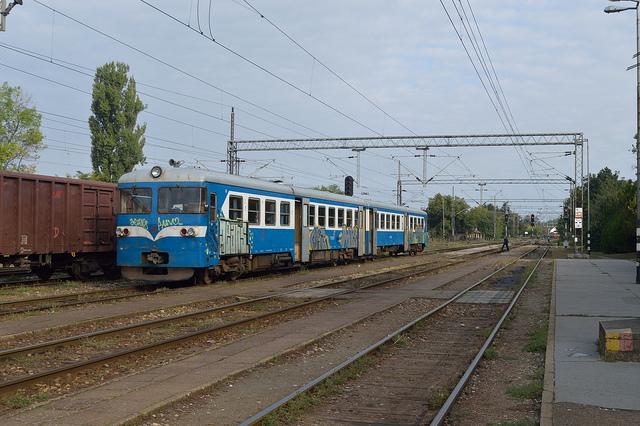How many tracks are seen?
Give a very brief answer. 3. What color is on the front of the train?
Short answer required. Blue. How many sets of tracks are there?
Concise answer only. 4. Is there a clock on top of the tracks?
Be succinct. No. Has the train lights been switched on?
Quick response, please. No. What is the train parked beside?
Give a very brief answer. Another train. Are the train's headlights on?
Short answer required. No. What color is the second car?
Short answer required. Blue. What color is the train?
Give a very brief answer. Blue. Are there people in the train?
Be succinct. No. What color is the train in the background?
Keep it brief. Blue. How many cars does the train have?
Keep it brief. 4. Are there people on the platform?
Give a very brief answer. No. Are the trains pulling out of the station?
Answer briefly. No. Is the train for passengers?
Be succinct. Yes. Is this train pulling into a station?
Quick response, please. No. What color is the front of the train?
Give a very brief answer. Blue. Are there mountains in the background?
Be succinct. No. Is the trains being used?
Be succinct. Yes. How many cars on this train?
Answer briefly. 4. Which train has white lights?
Be succinct. Blue. Is the train in motion?
Write a very short answer. No. How many tracks are there?
Be succinct. 4. How many different trains are on the tracks?
Write a very short answer. 2. Is the train passing through a city?
Be succinct. No. What colors is the train engine?
Be succinct. Blue. What color is the majority of the train?
Answer briefly. Blue. 